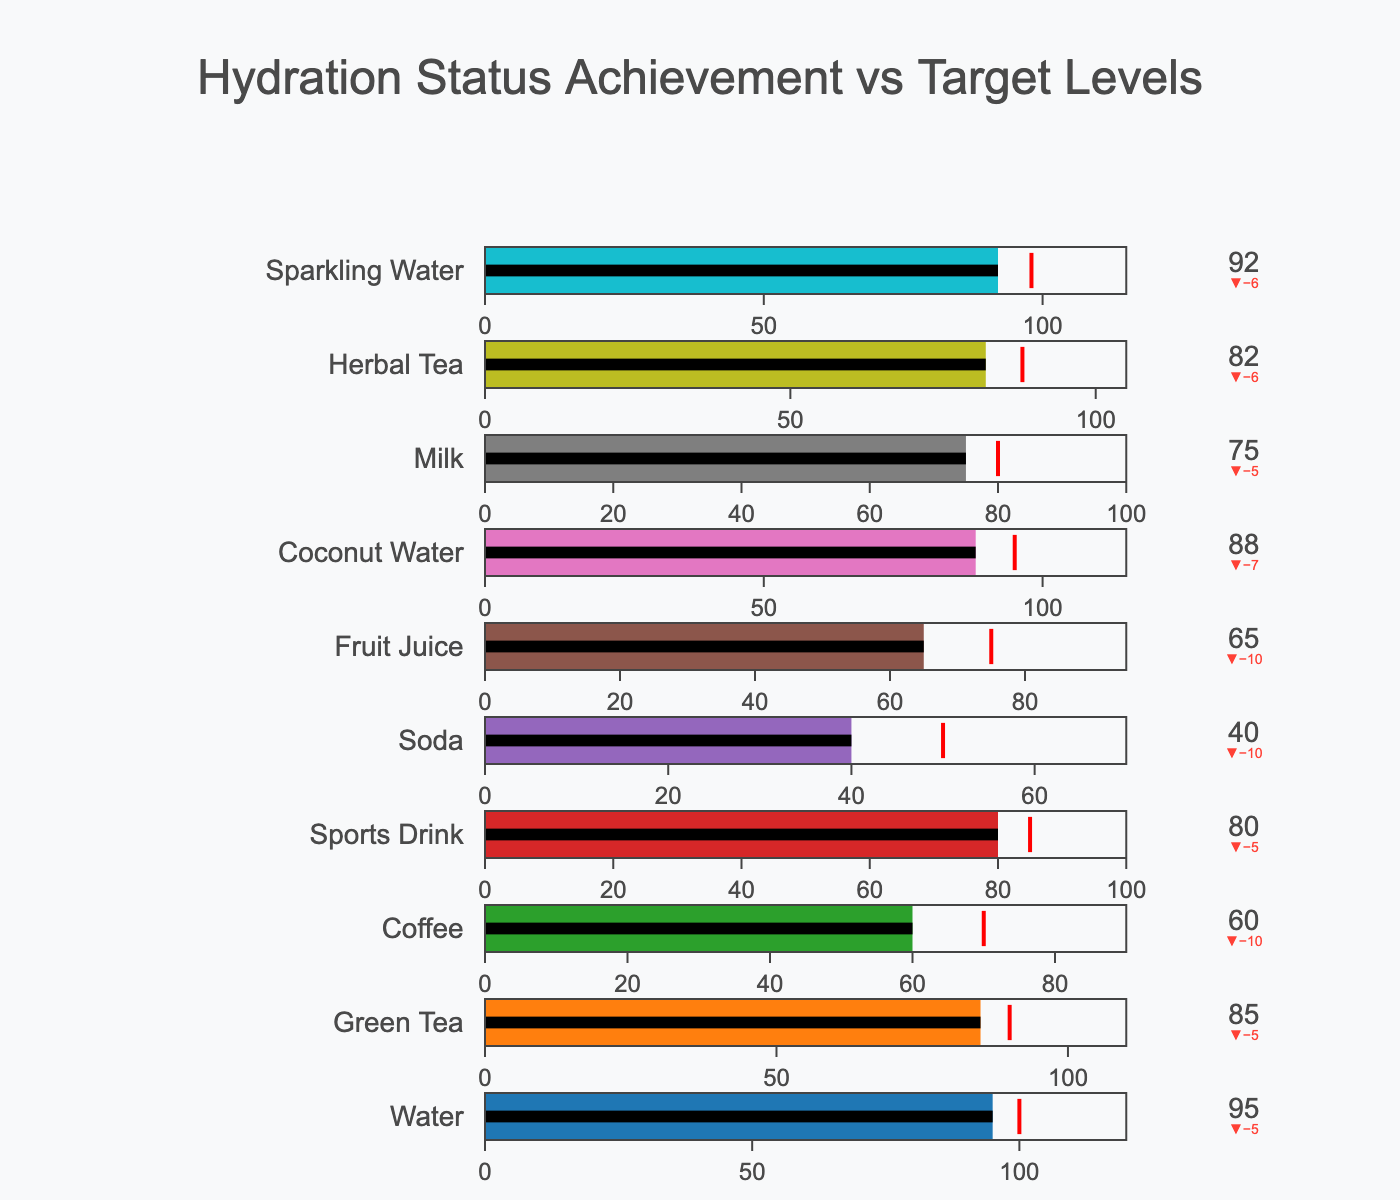What's the title of the figure? The title is usually placed at the top center of the figure, which in this case is "Hydration Status Achievement vs Target Levels".
Answer: Hydration Status Achievement vs Target Levels How many beverage types are represented in the figure? Each beverage type should be listed with its respective bullet chart, so counting the number of bullet charts will give the answer. There are 10 beverage types.
Answer: 10 Which beverage type has the highest actual hydration? Look for the bullet chart where the actual hydration value is the highest. The figure shows Water with an actual hydration level of 95.
Answer: Water Which beverage type has an actual hydration level closest to its target hydration? To find this, compare the difference (or delta) between the actual and target hydration for each beverage type. Green Tea has an actual hydration of 85 and a target of 90, making it the closest with a difference of 5.
Answer: Green Tea Which beverage types have actual hydration values below their target hydration levels? Identify the beverage types where the actual hydration is less than the target. For Coffee, Soda, Fruit Juice, and Milk, the actual hydration levels are below their target levels.
Answer: Coffee, Soda, Fruit Juice, Milk For which beverage type is the target hydration level furthest from the actual hydration level? Calculate the difference between the actual and target for each beverage type, and identify the largest difference. Soda, with an actual hydration of 40 and a target of 50, has the largest difference of 10.
Answer: Soda What is the difference between the actual hydration levels of Sparkling Water and Green Tea? Subtract the actual hydration level of Green Tea from Sparkling Water. Sparkling Water has 92, and Green Tea has 85, so the difference is 92 - 85 = 7.
Answer: 7 Which beverage types have actual hydration levels above 80? Look at the actual hydration values and list those that are greater than 80. Water, Green Tea, Sports Drink, Coconut Water, Herbal Tea, and Sparkling Water all have actual hydration levels above 80.
Answer: Water, Green Tea, Sports Drink, Coconut Water, Herbal Tea, Sparkling Water How does the actual hydration of Milk compare to the target hydration of Sports Drink? Check the actual hydration of Milk, which is 75, and the target hydration of Sports Drink, which is 85. Milk's actual hydration is less than the target hydration of Sports Drink.
Answer: Less Which beverage type has the smallest range from zero to maximum hydration? Look for the beverage type with the smallest maximum hydration value. Soda has the lowest maximum hydration value of 70.
Answer: Soda 